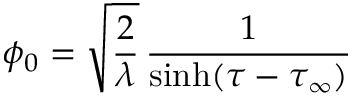<formula> <loc_0><loc_0><loc_500><loc_500>\phi _ { 0 } = \sqrt { \frac { 2 } { \lambda } } \, { \frac { 1 } { \sinh ( \tau - \tau _ { \infty } ) } }</formula> 